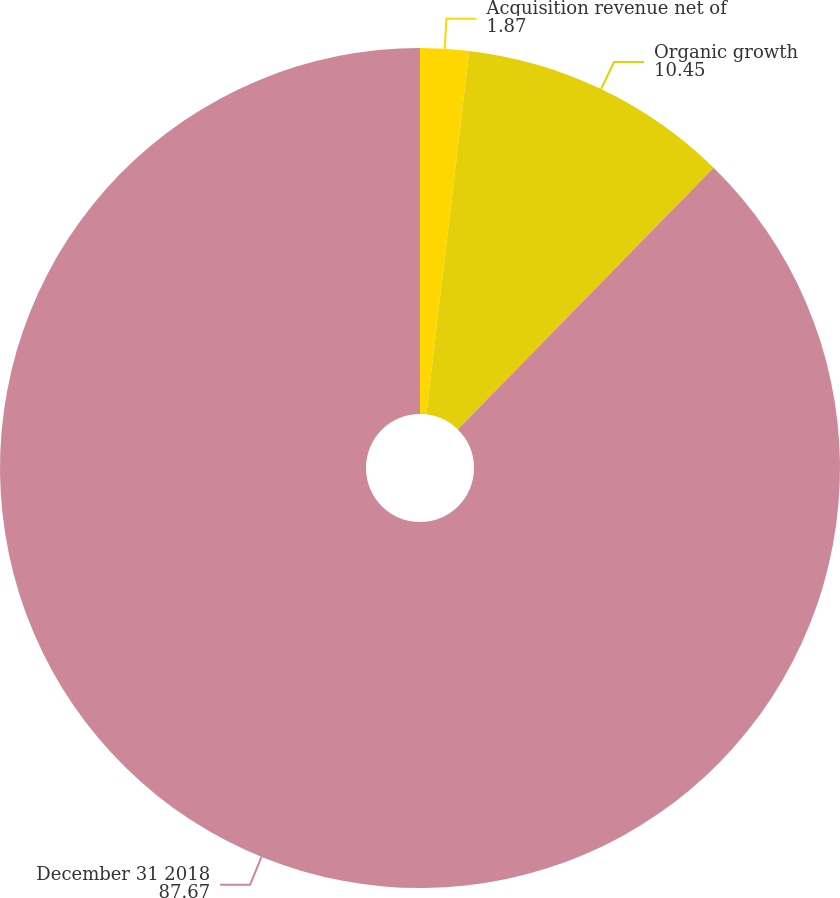Convert chart to OTSL. <chart><loc_0><loc_0><loc_500><loc_500><pie_chart><fcel>Acquisition revenue net of<fcel>Organic growth<fcel>December 31 2018<nl><fcel>1.87%<fcel>10.45%<fcel>87.67%<nl></chart> 